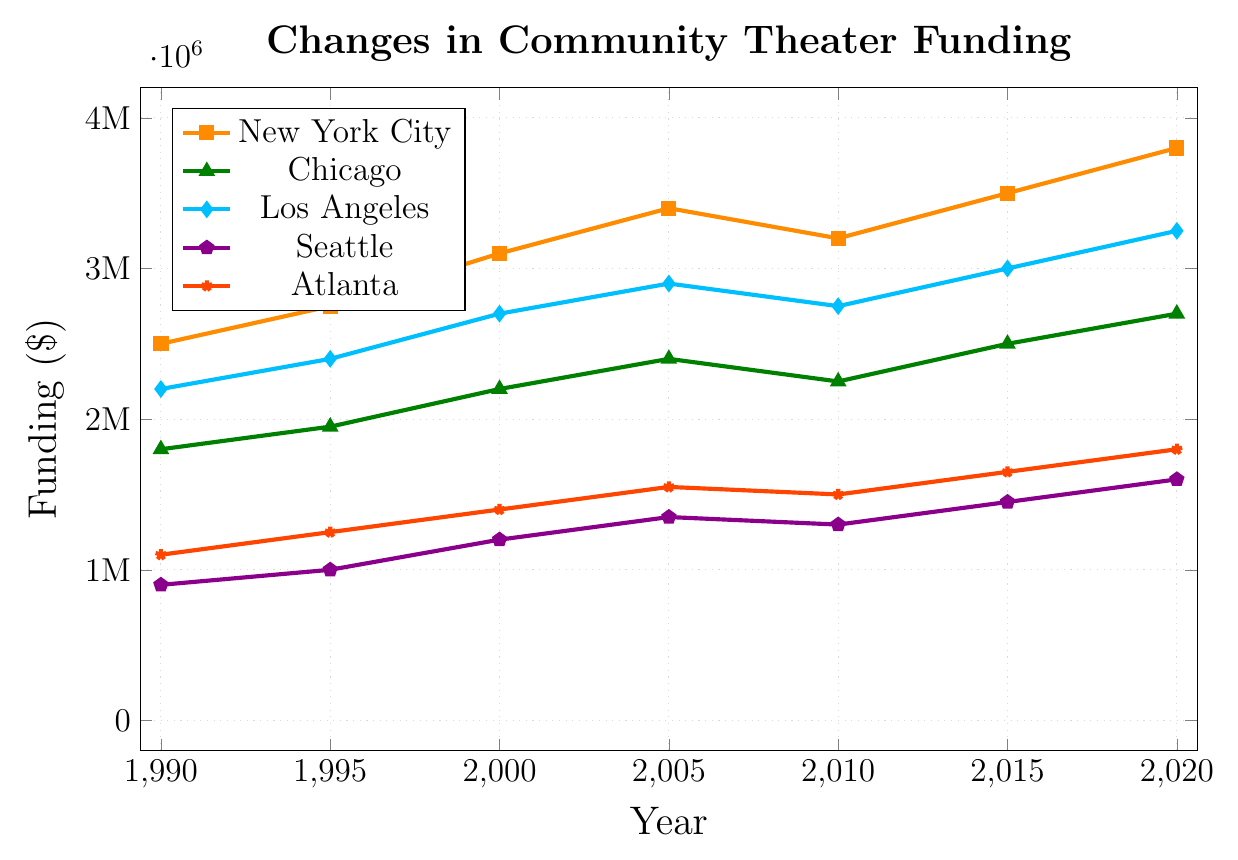What trend do you observe for New York City's funding from 1990 to 2020? From 1990 to 2020, New York City's funding consistently increased from $2,500,000 to $3,800,000, except for a dip in 2010.
Answer: Consistent increase with a dip in 2010 Which city had the highest funding in 2020? By looking at the data points for 2020, New York City has the highest funding at $3,800,000.
Answer: New York City How did Chicago's funding change between 2000 and 2015? Chicago's funding increased from $2,200,000 in 2000 to $2,500,000 in 2015.
Answer: Increased by $300,000 Compare the funding for Los Angeles and Seattle in 2005. Which city had higher funding and by how much? Los Angeles had a funding of $2,900,000, while Seattle had $1,350,000 in 2005. The difference is $2,900,000 - $1,350,000 = $1,550,000.
Answer: Los Angeles by $1,550,000 What is the average funding for Atlanta over the period 1990 to 2020? Sum of Atlanta's funding from 1990 to 2020 is 11,250,000 (i.e., 1,100,000 + 1,250,000 + 1,400,000 + 1,550,000 + 1,500,000 + 1,650,000 + 1,800,000). The average is 11,250,000 / 7 = 1,607,143.
Answer: $1,607,143 Which city experienced the smallest increase in funding from 1990 to 2020? Seattle's funding increased from $900,000 in 1990 to $1,600,000 in 2020, an increase of $700,000. This is the smallest increase among the cities.
Answer: Seattle Identify the year when New York City's funding experienced a decline. By visually inspecting the line for New York City, there is a visible decline between 2005 and 2010.
Answer: 2010 What visuals help identify which city had the most irregular funding pattern? Observing the dips, rises, and fluctuations in the lines can help identify irregular patterns. New York City shows a noticeable dip around 2010, suggesting a break in otherwise steady increases.
Answer: Line patterns and dips 